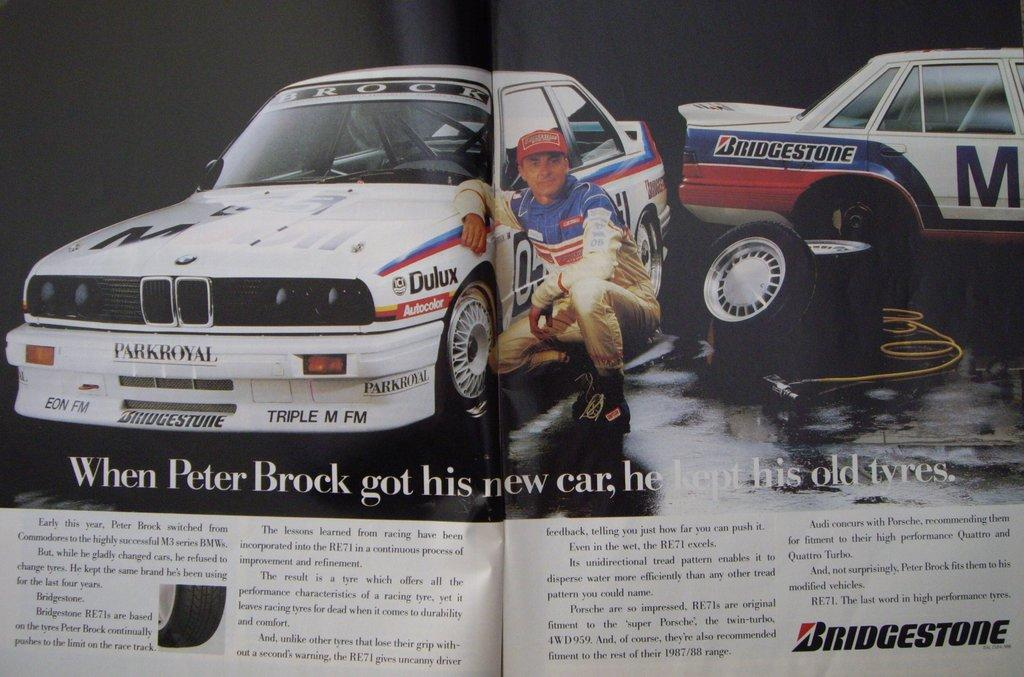What is the main subject of the paper in the image? The paper contains images of cars. Is there any other element depicted on the paper besides the cars? Yes, there is a man depicted on the paper. What type of hill can be seen in the background of the image? There is no hill present in the image; it features a paper with images of cars and a man. Can you tell me how many appliances are visible in the image? There are no appliances present in the image; it features a paper with images of cars and a man. 